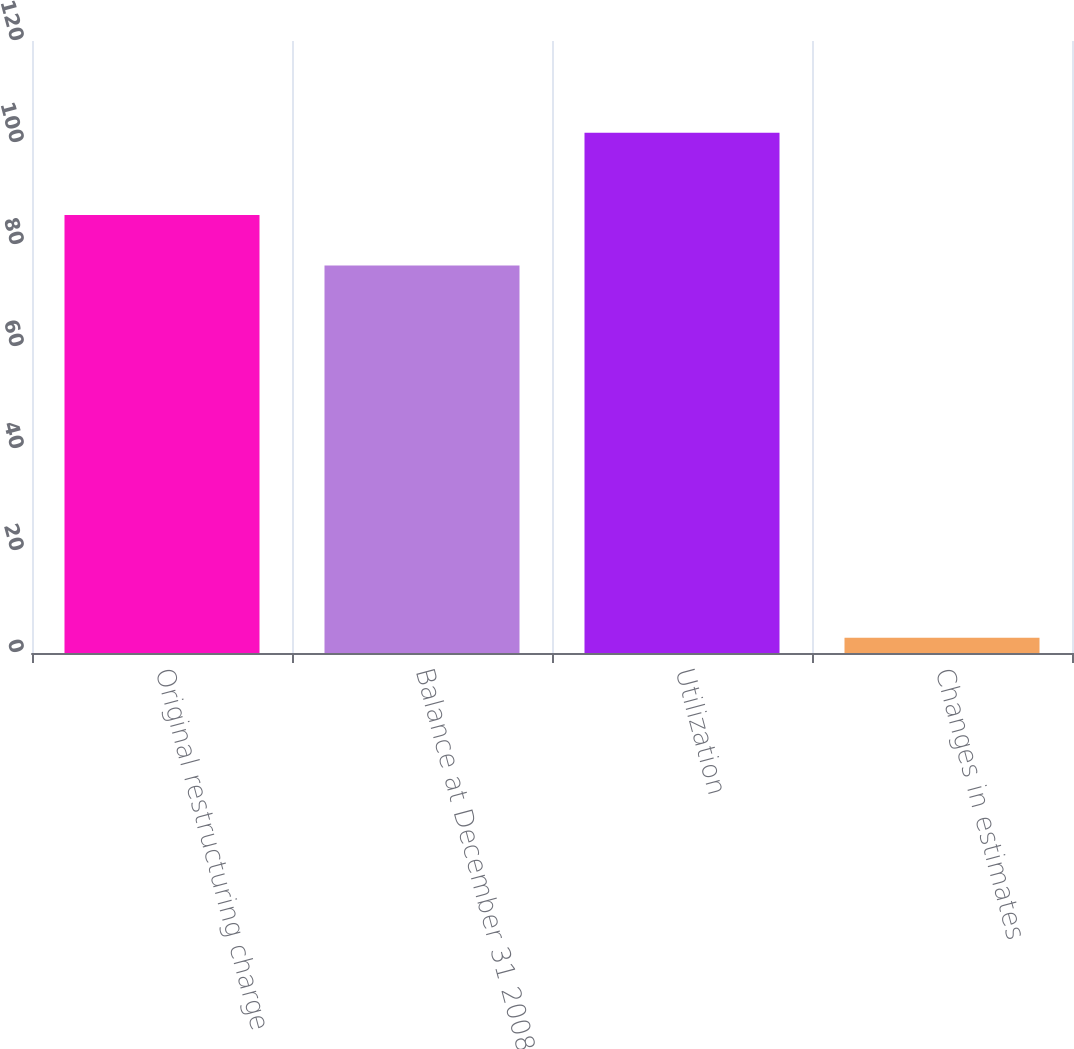Convert chart. <chart><loc_0><loc_0><loc_500><loc_500><bar_chart><fcel>Original restructuring charge<fcel>Balance at December 31 2008<fcel>Utilization<fcel>Changes in estimates<nl><fcel>85.9<fcel>76<fcel>102<fcel>3<nl></chart> 